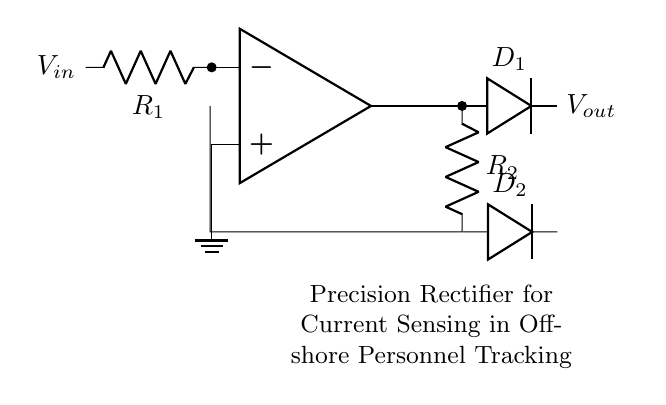What is the type of rectifier used in this circuit? The circuit diagram includes components typical of a precision rectifier, which utilizes operational amplifiers and diodes.
Answer: precision rectifier What is the function of the operational amplifier in this circuit? The operational amplifier amplifies the input voltage and allows for accurate rectification of the input current, enabling precision in current sensing.
Answer: amplifying input voltage How many diodes are present in the circuit? By examining the circuit diagram, we can see there are two diodes labeled D1 and D2.
Answer: two What is the role of resistor R1 in this circuit? R1 is connected to the inverting input of the operational amplifier, which aids in the control of the input signal and defines the gain for the rectifier.
Answer: control input signal What is the output voltage represented by in the circuit? The output voltage is labeled Vout, which indicates the voltage at the output terminal of the precision rectifier circuit, allowing for accurate sensing of current.
Answer: Vout What is the purpose of using two diodes in a precision rectifier configuration? The two diodes facilitate the rectification process, allowing for both the positive and negative halves of the input signal to be accurately processed, thus improving the precision.
Answer: improve precision How does the ground connection affect this circuit's operation? The ground connection establishes a reference point for the input voltage and aids in the overall stability of the circuit, ensuring accurate operation of the operational amplifier.
Answer: stability and reference point 